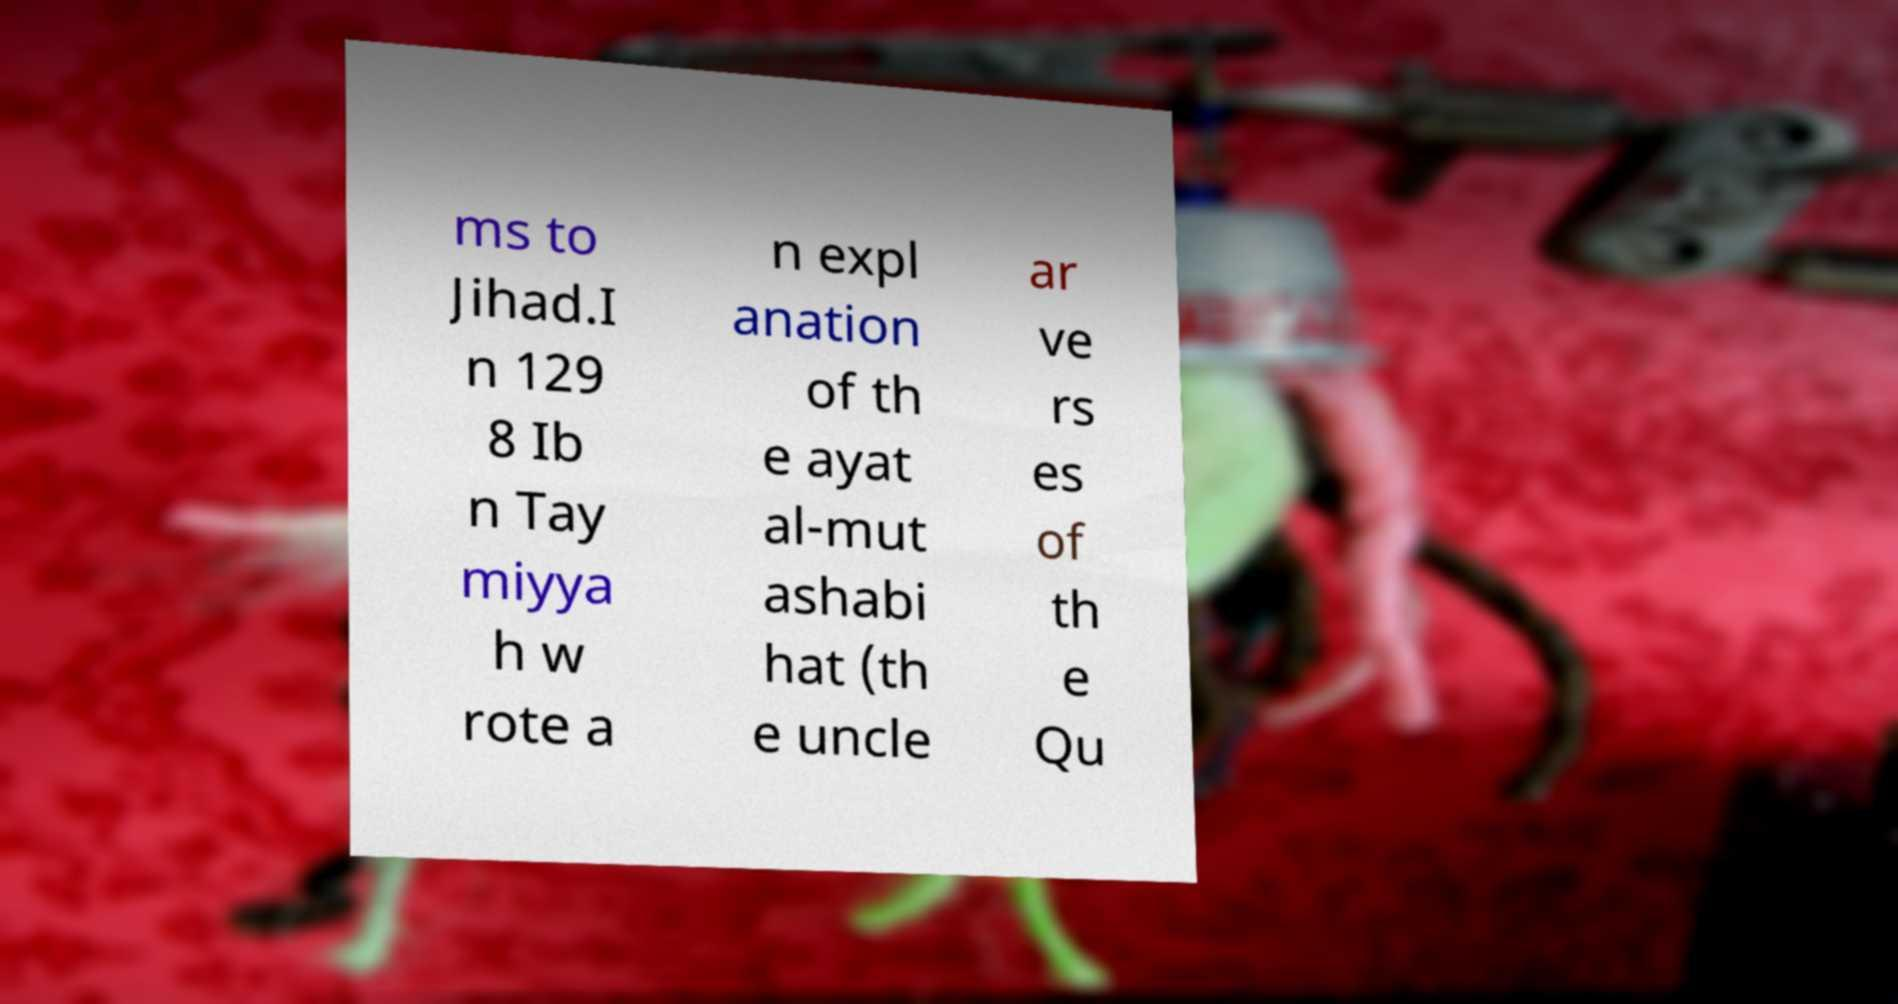Could you extract and type out the text from this image? ms to Jihad.I n 129 8 Ib n Tay miyya h w rote a n expl anation of th e ayat al-mut ashabi hat (th e uncle ar ve rs es of th e Qu 